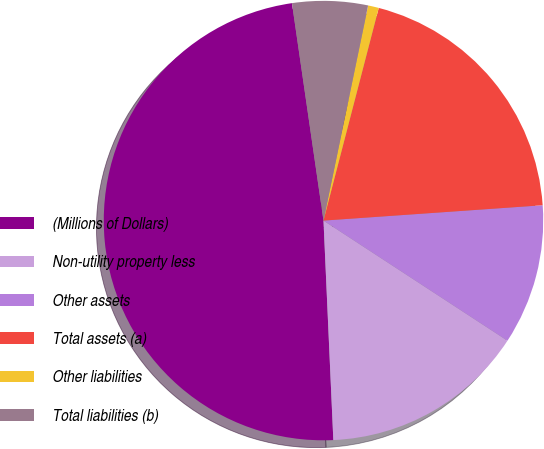<chart> <loc_0><loc_0><loc_500><loc_500><pie_chart><fcel>(Millions of Dollars)<fcel>Non-utility property less<fcel>Other assets<fcel>Total assets (a)<fcel>Other liabilities<fcel>Total liabilities (b)<nl><fcel>48.42%<fcel>15.08%<fcel>10.32%<fcel>19.84%<fcel>0.79%<fcel>5.55%<nl></chart> 